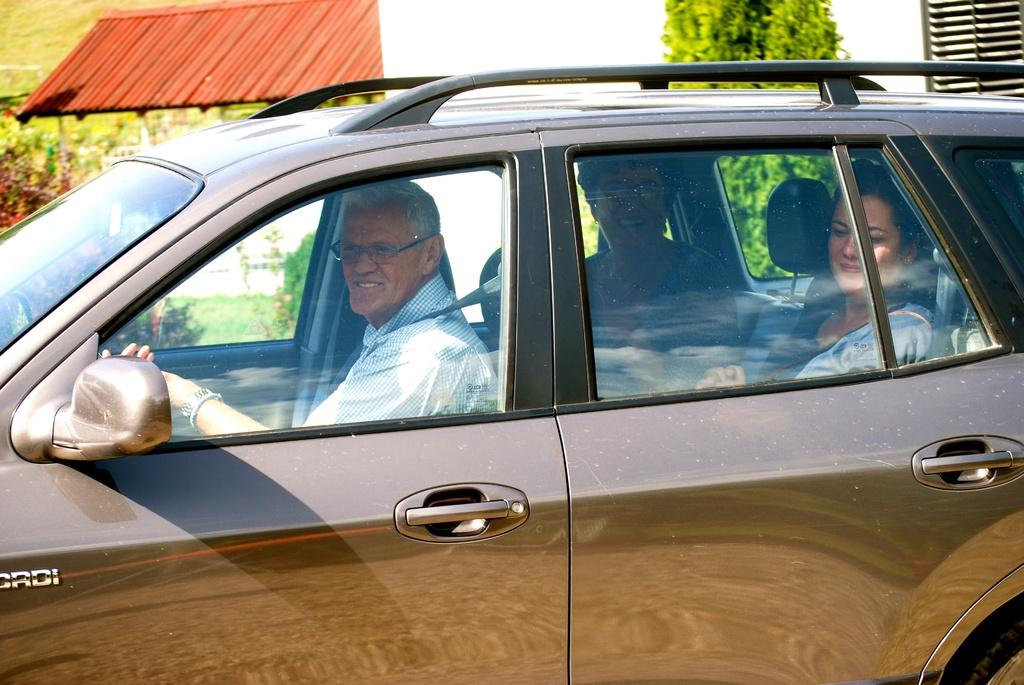How many people are in the image? There are three persons in the image. Where are the three persons located? The three persons are sitting inside a vehicle. What can be seen in the background of the image? There is a shed and a tree in the background of the image. What expressions do the three persons have? The three persons are holding smiles. What hobbies are the three persons engaged in while sitting inside the vehicle? There is no information about the hobbies of the three persons in the image. --- Facts: 1. There is a person holding a camera in the image. 2. The person is standing on a bridge. 3. There is a river flowing under the bridge. 4. The sky is visible in the image. 5. There are clouds in the sky. Absurd Topics: painting, dance, recipe Conversation: What is the person in the image holding? The person in the image is holding a camera. Where is the person standing in the image? The person is standing on a bridge. What can be seen below the bridge in the image? There is a river flowing under the bridge. What is visible at the top of the image? The sky is visible in the image. What can be observed in the sky? There are clouds in the sky. Reasoning: Let's think step by step in order to produce the conversation. We start by identifying the main subject in the image, which is the person holding a camera. Then, we describe their location, which is on a bridge. Next, we mention the river flowing under the bridge and the visible sky with clouds. Each question is designed to elicit a specific detail about the image that is known from the provided facts. Absurd Question/Answer: What type of painting is the person creating while standing on the bridge? There is no information about the person creating a painting in the image. 